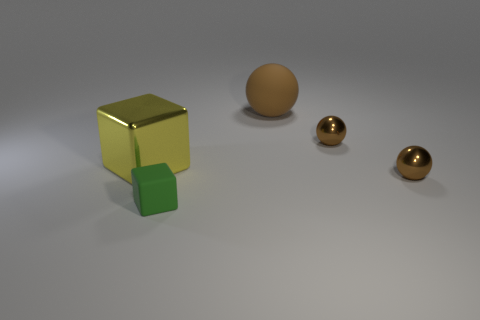Subtract all rubber spheres. How many spheres are left? 2 Add 2 spheres. How many objects exist? 7 Subtract 1 spheres. How many spheres are left? 2 Subtract all purple spheres. Subtract all green cylinders. How many spheres are left? 3 Subtract all blocks. How many objects are left? 3 Subtract all big red shiny spheres. Subtract all brown matte objects. How many objects are left? 4 Add 1 small shiny spheres. How many small shiny spheres are left? 3 Add 2 tiny green objects. How many tiny green objects exist? 3 Subtract 0 purple cylinders. How many objects are left? 5 